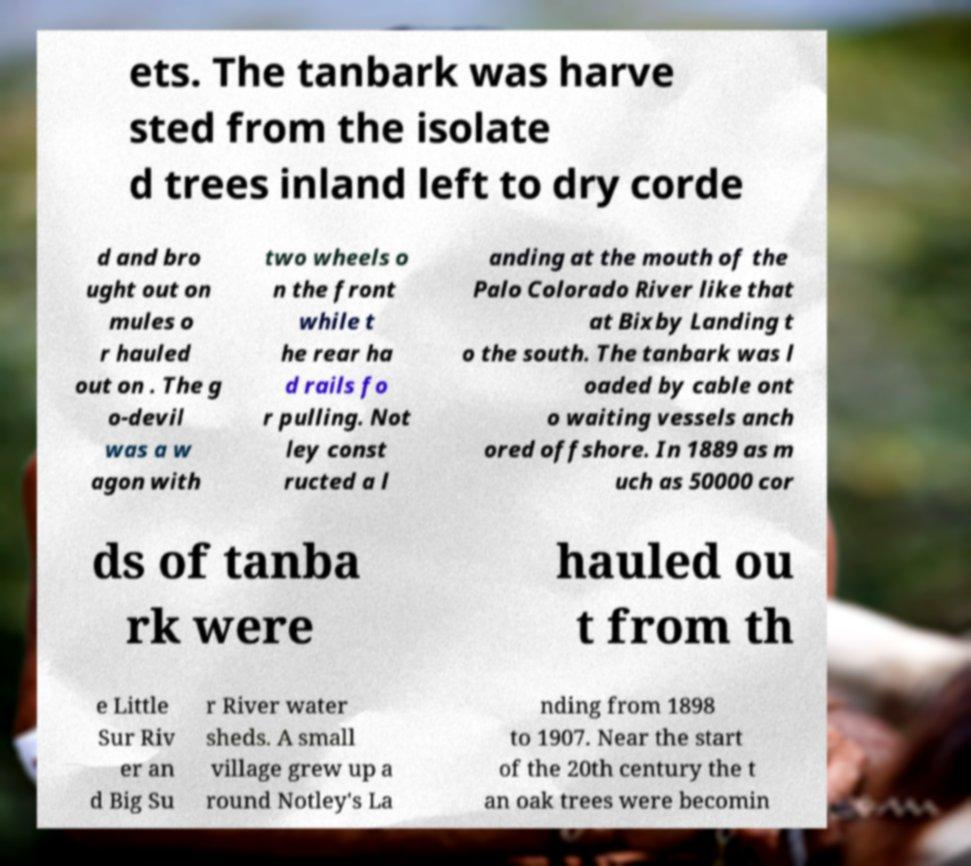For documentation purposes, I need the text within this image transcribed. Could you provide that? ets. The tanbark was harve sted from the isolate d trees inland left to dry corde d and bro ught out on mules o r hauled out on . The g o-devil was a w agon with two wheels o n the front while t he rear ha d rails fo r pulling. Not ley const ructed a l anding at the mouth of the Palo Colorado River like that at Bixby Landing t o the south. The tanbark was l oaded by cable ont o waiting vessels anch ored offshore. In 1889 as m uch as 50000 cor ds of tanba rk were hauled ou t from th e Little Sur Riv er an d Big Su r River water sheds. A small village grew up a round Notley's La nding from 1898 to 1907. Near the start of the 20th century the t an oak trees were becomin 